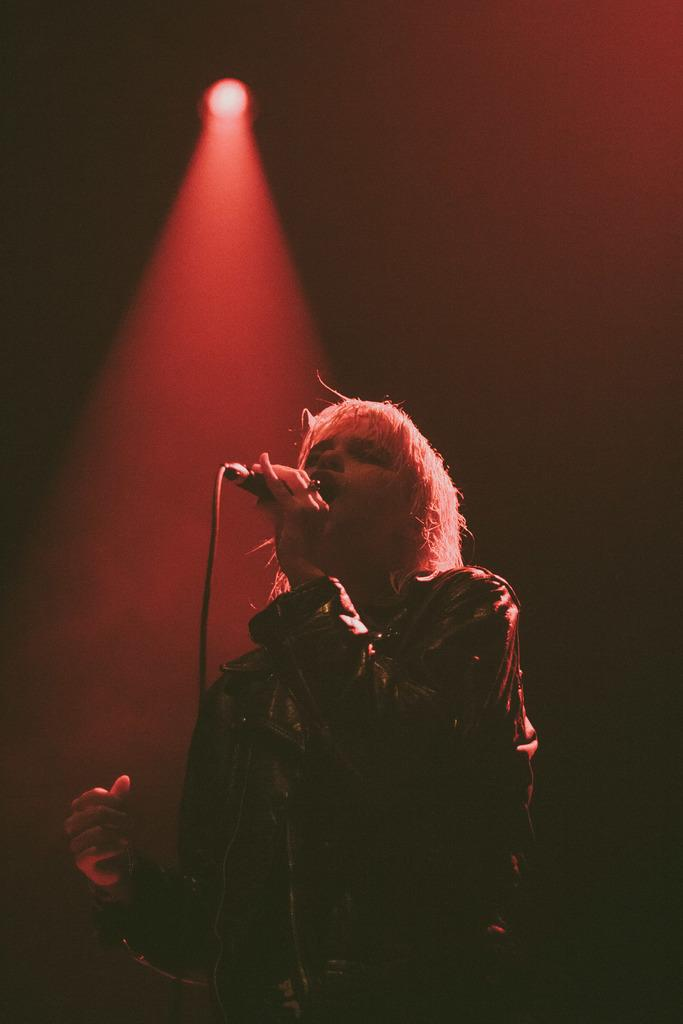What is the main subject of the image? The main subject of the image is a man. What is the man holding in the image? The man is holding a mic with his hands. Can you describe any additional features in the image? Yes, there is a red light visible at the top of the image. What type of celery is being used as a prop in the image? There is no celery present in the image. Can you describe the boundary of the image? The boundary of the image refers to the edges of the photograph, which are not visible in the image itself. 